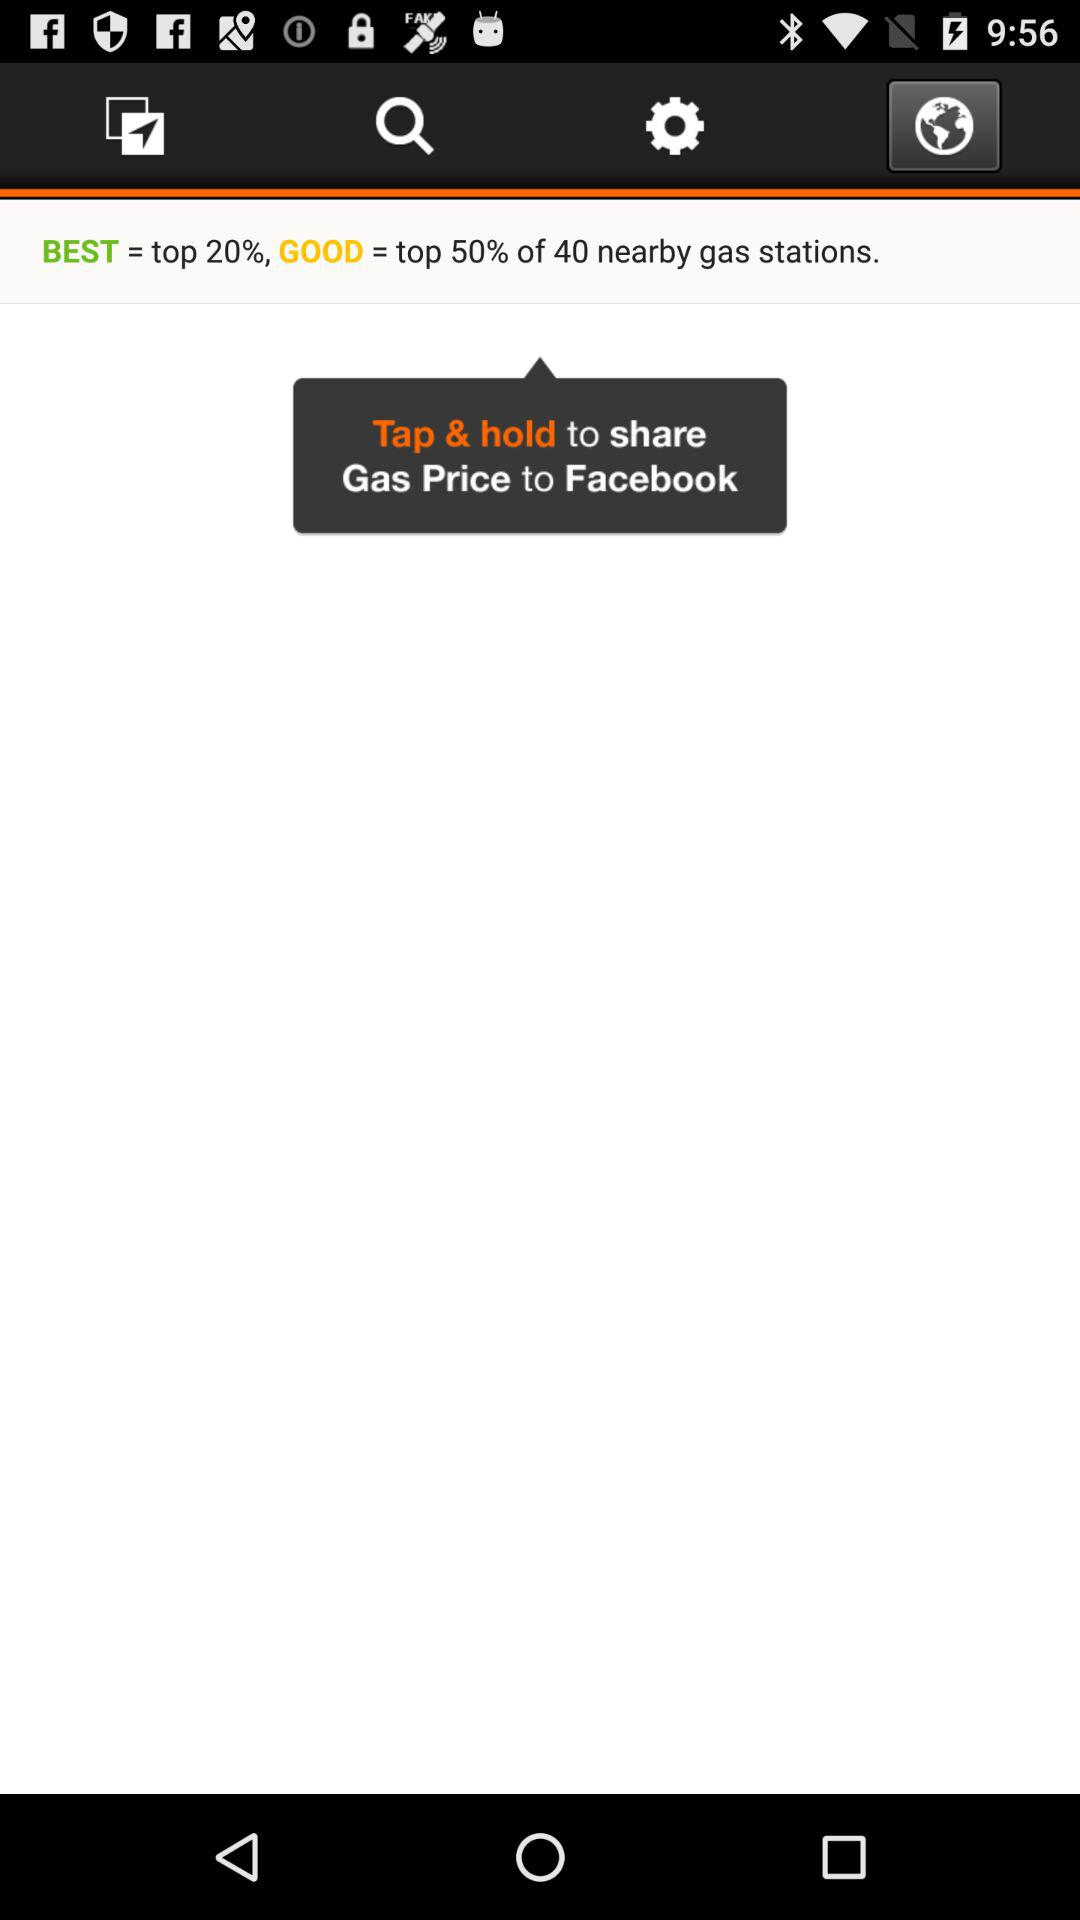Which tab is currently selected? The currently selected tab is "Notification". 